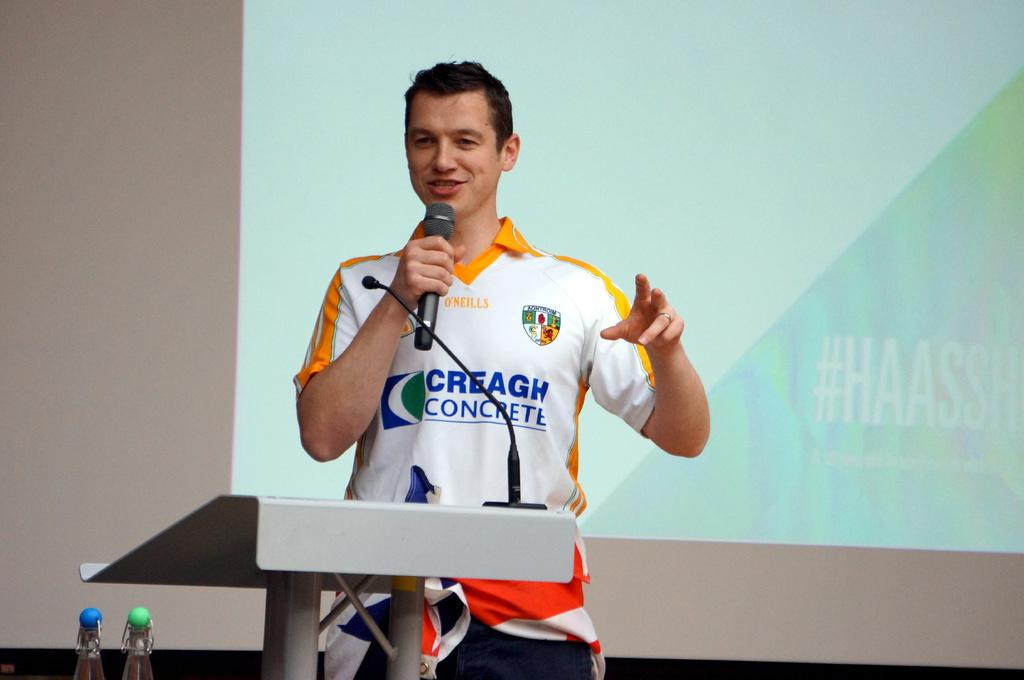<image>
Present a compact description of the photo's key features. A young man in a Creagh Concrete shirt speaks into a microphone. 